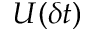Convert formula to latex. <formula><loc_0><loc_0><loc_500><loc_500>U ( \delta t )</formula> 